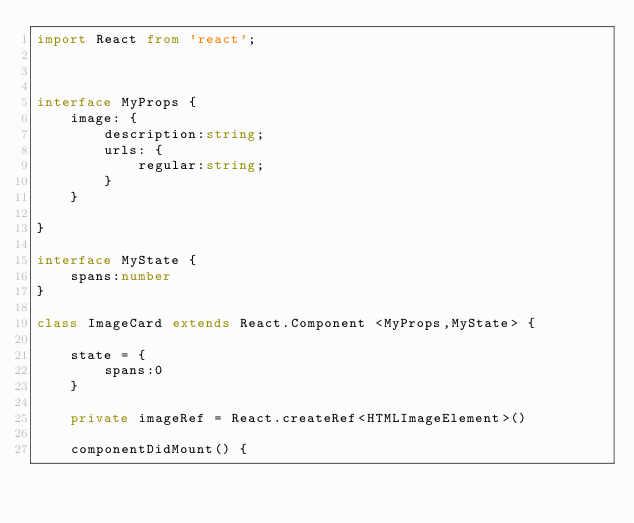<code> <loc_0><loc_0><loc_500><loc_500><_TypeScript_>import React from 'react';



interface MyProps {
    image: {         
        description:string;
        urls: {
            regular:string;
        }
    }   
    
}

interface MyState {
    spans:number
}

class ImageCard extends React.Component <MyProps,MyState> {

    state = {
        spans:0
    }

    private imageRef = React.createRef<HTMLImageElement>()

    componentDidMount() {</code> 